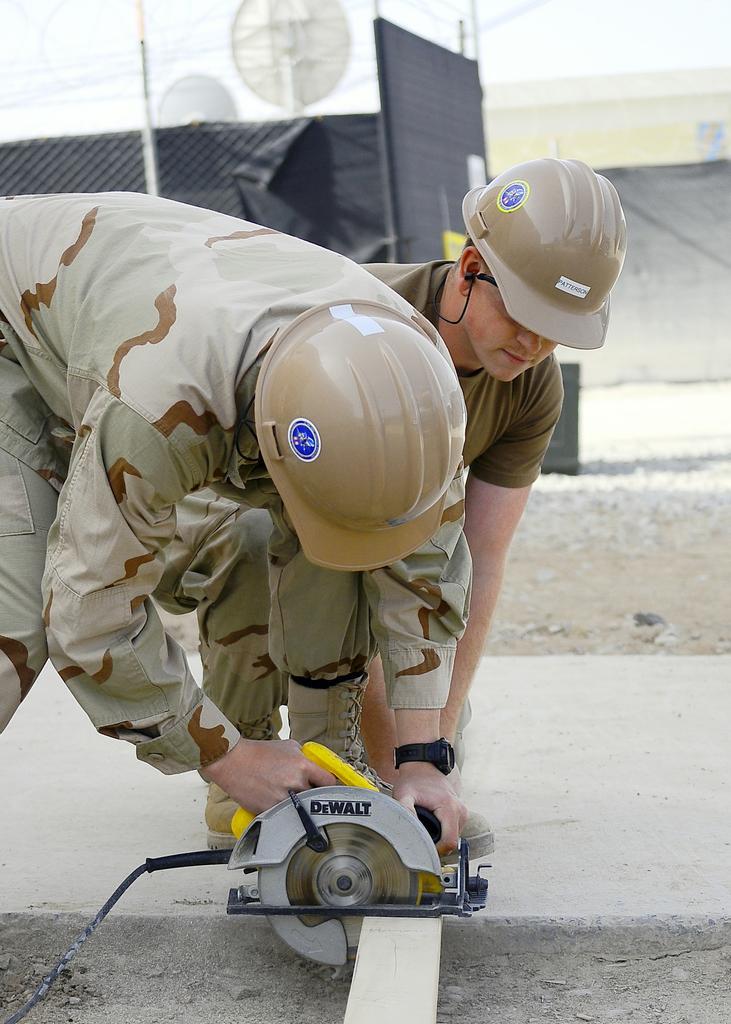How would you summarize this image in a sentence or two? In the picture we can see two people in the uniforms and helmet, they are bending and cutting some iron rod with a cutting machine and in the background, we can see a fencing with a pole and behind it we can see some black color walls. 